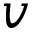Convert formula to latex. <formula><loc_0><loc_0><loc_500><loc_500>v</formula> 